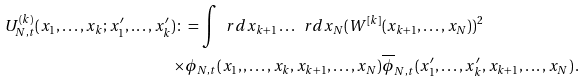<formula> <loc_0><loc_0><loc_500><loc_500>U ^ { ( k ) } _ { N , t } ( x _ { 1 } , \dots , x _ { k } ; x _ { 1 } ^ { \prime } , \dots , x _ { k } ^ { \prime } ) \colon = \int \ r d x _ { k + 1 } \dots \ r d x _ { N } ( W ^ { [ k ] } & ( x _ { k + 1 } , \dots , x _ { N } ) ) ^ { 2 } \\ \times \phi _ { N , t } ( x _ { 1 } , , \dots , x _ { k } , x _ { k + 1 } , \dots , x _ { N } ) & \overline { \phi } _ { N , t } ( x _ { 1 } ^ { \prime } , \dots , x _ { k } ^ { \prime } , x _ { k + 1 } , \dots , x _ { N } ) \, .</formula> 